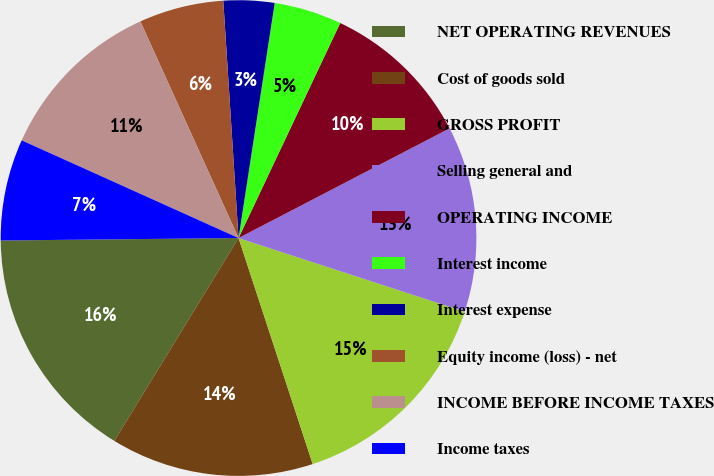Convert chart. <chart><loc_0><loc_0><loc_500><loc_500><pie_chart><fcel>NET OPERATING REVENUES<fcel>Cost of goods sold<fcel>GROSS PROFIT<fcel>Selling general and<fcel>OPERATING INCOME<fcel>Interest income<fcel>Interest expense<fcel>Equity income (loss) - net<fcel>INCOME BEFORE INCOME TAXES<fcel>Income taxes<nl><fcel>16.09%<fcel>13.79%<fcel>14.94%<fcel>12.64%<fcel>10.34%<fcel>4.6%<fcel>3.45%<fcel>5.75%<fcel>11.49%<fcel>6.9%<nl></chart> 